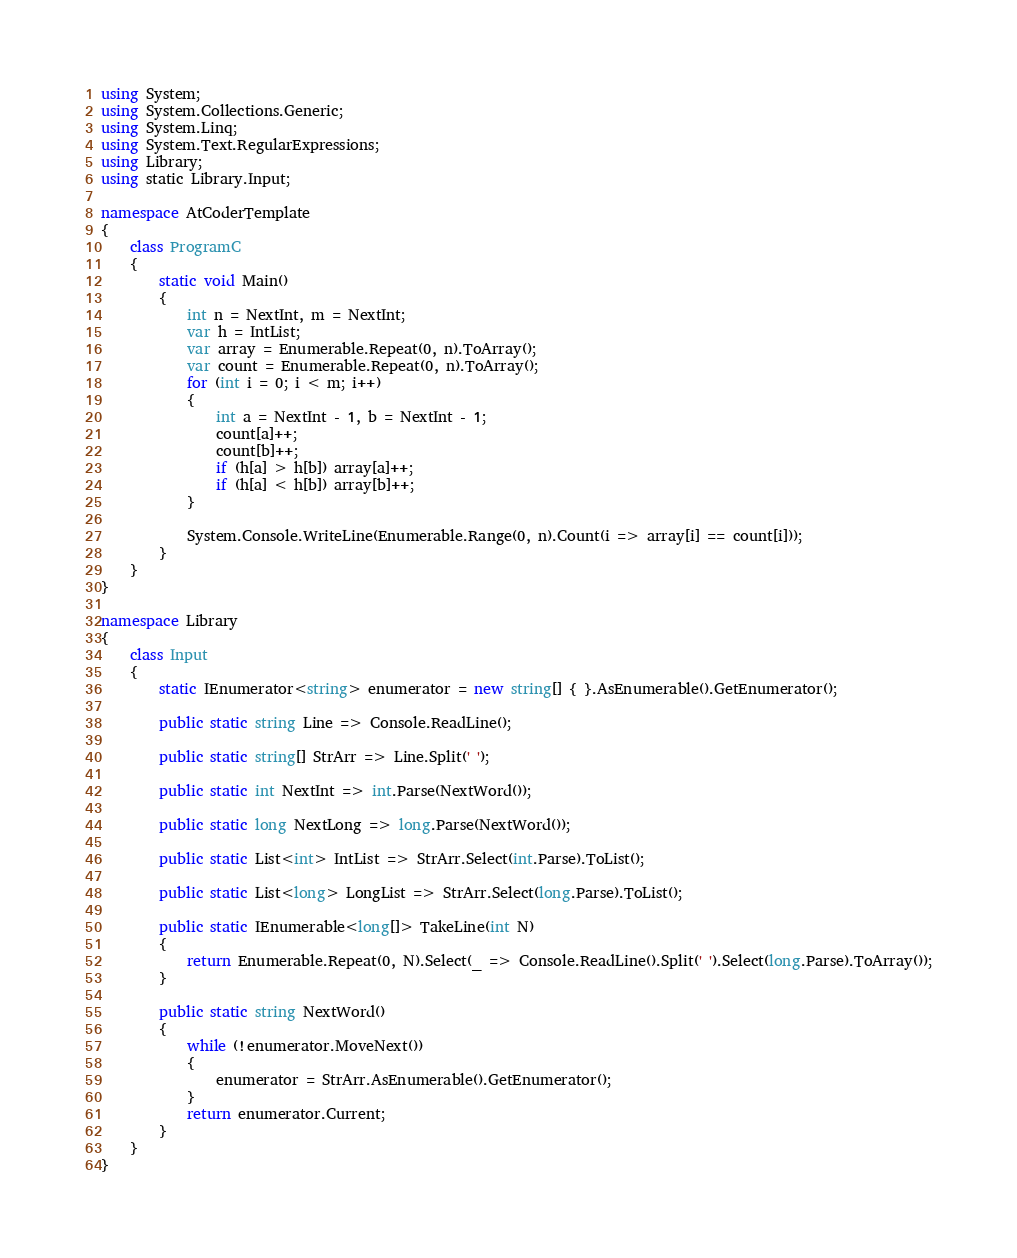<code> <loc_0><loc_0><loc_500><loc_500><_C#_>using System;
using System.Collections.Generic;
using System.Linq;
using System.Text.RegularExpressions;
using Library;
using static Library.Input;

namespace AtCoderTemplate
{
    class ProgramC
    {
        static void Main()
        {
            int n = NextInt, m = NextInt;
            var h = IntList;
            var array = Enumerable.Repeat(0, n).ToArray();
            var count = Enumerable.Repeat(0, n).ToArray();
            for (int i = 0; i < m; i++)
            {
                int a = NextInt - 1, b = NextInt - 1;
                count[a]++;
                count[b]++;
                if (h[a] > h[b]) array[a]++;
                if (h[a] < h[b]) array[b]++;
            }

            System.Console.WriteLine(Enumerable.Range(0, n).Count(i => array[i] == count[i]));
        }
    }
}

namespace Library
{
    class Input
    {
        static IEnumerator<string> enumerator = new string[] { }.AsEnumerable().GetEnumerator();

        public static string Line => Console.ReadLine();

        public static string[] StrArr => Line.Split(' ');

        public static int NextInt => int.Parse(NextWord());

        public static long NextLong => long.Parse(NextWord());

        public static List<int> IntList => StrArr.Select(int.Parse).ToList();

        public static List<long> LongList => StrArr.Select(long.Parse).ToList();

        public static IEnumerable<long[]> TakeLine(int N)
        {
            return Enumerable.Repeat(0, N).Select(_ => Console.ReadLine().Split(' ').Select(long.Parse).ToArray());
        }

        public static string NextWord()
        {
            while (!enumerator.MoveNext())
            {
                enumerator = StrArr.AsEnumerable().GetEnumerator();
            }
            return enumerator.Current;
        }
    }
}
</code> 